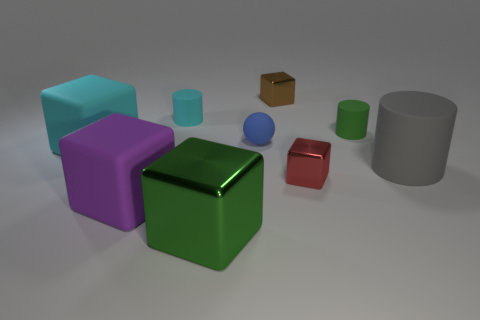Are there any cylinders of the same color as the matte ball?
Your answer should be compact. No. Are there an equal number of brown objects in front of the gray matte thing and brown blocks?
Offer a terse response. No. Do the large metallic object and the sphere have the same color?
Your answer should be very brief. No. What size is the matte object that is in front of the large cyan object and on the left side of the gray thing?
Offer a very short reply. Large. There is a small ball that is made of the same material as the tiny cyan cylinder; what is its color?
Offer a very short reply. Blue. What number of red blocks have the same material as the brown block?
Offer a terse response. 1. Are there the same number of small shiny objects that are behind the tiny brown metal thing and tiny things right of the small red block?
Make the answer very short. No. Do the purple rubber object and the tiny matte object that is behind the tiny green rubber object have the same shape?
Provide a short and direct response. No. There is a small cylinder that is the same color as the big shiny object; what is it made of?
Offer a very short reply. Rubber. Is there anything else that is the same shape as the small brown shiny object?
Offer a very short reply. Yes. 